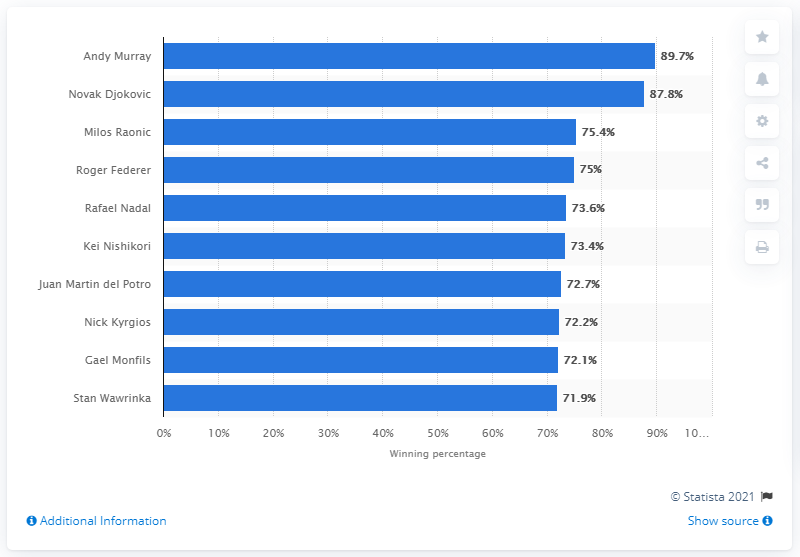Highlight a few significant elements in this photo. Andy Murray had the highest winning percentage of all male players in 2016. 